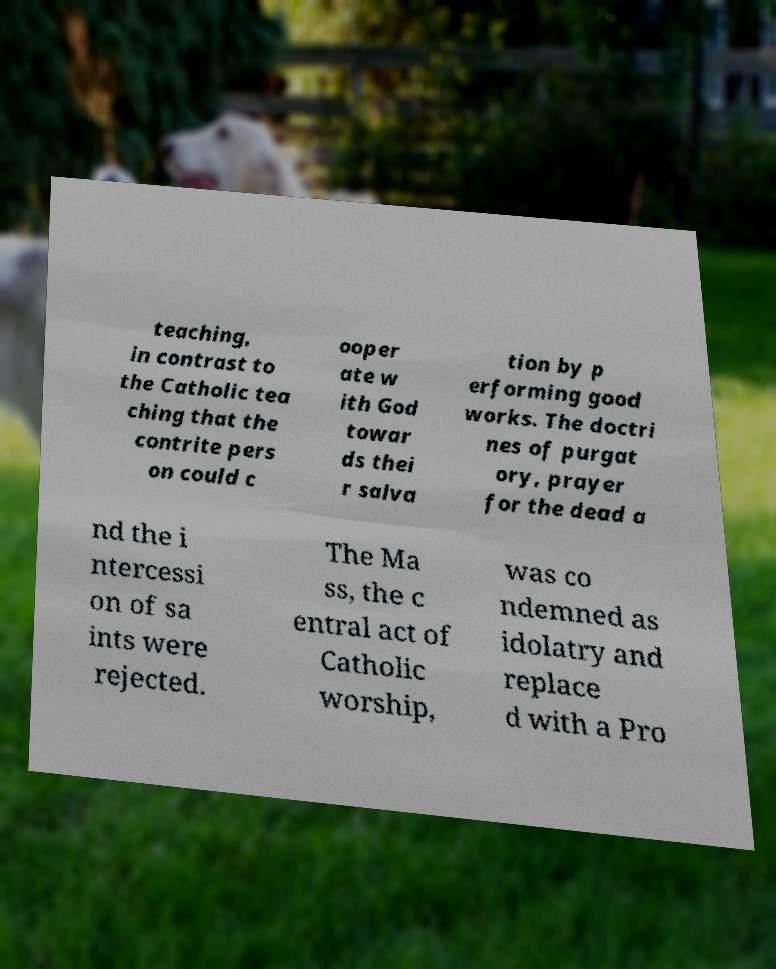Can you accurately transcribe the text from the provided image for me? teaching, in contrast to the Catholic tea ching that the contrite pers on could c ooper ate w ith God towar ds thei r salva tion by p erforming good works. The doctri nes of purgat ory, prayer for the dead a nd the i ntercessi on of sa ints were rejected. The Ma ss, the c entral act of Catholic worship, was co ndemned as idolatry and replace d with a Pro 